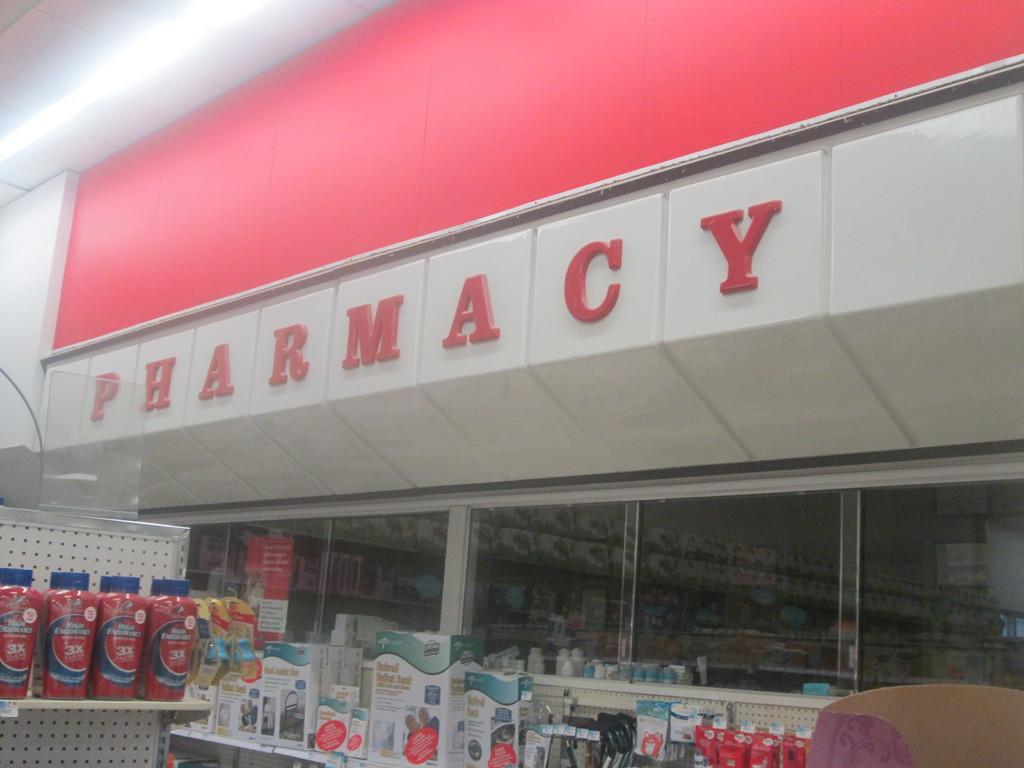Can you describe this image briefly? Here I can see a pharmacy. Here I can see many bottles and boxes which are arranged in the racks. At the top, I can see the wall and a red color board. 